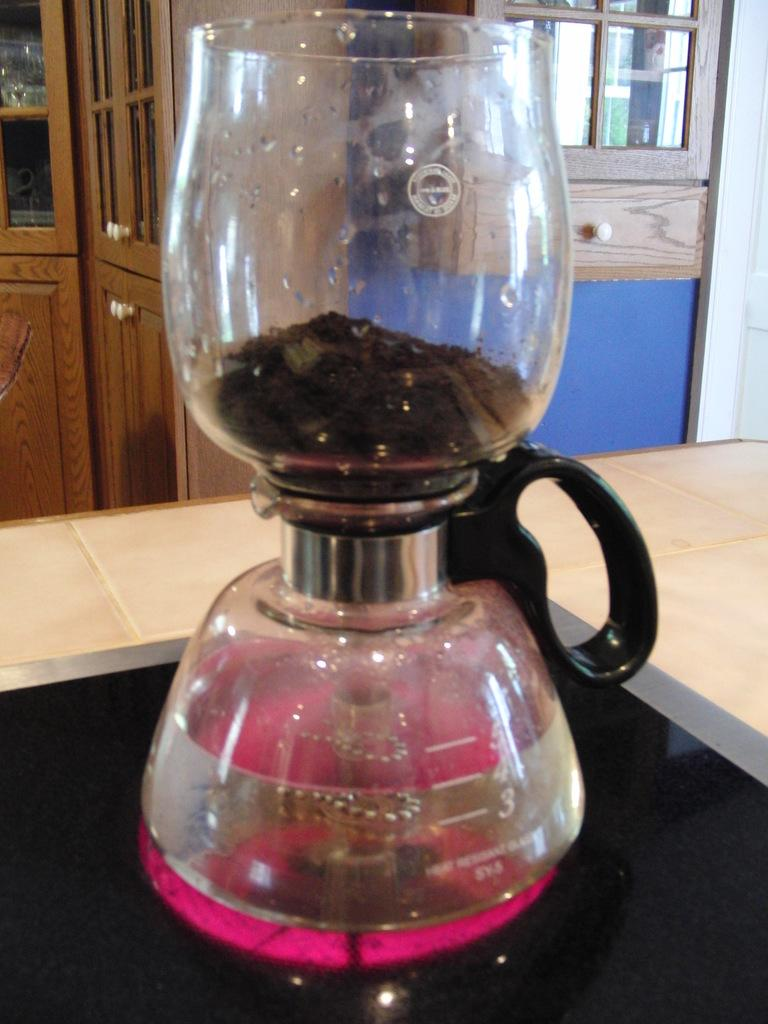<image>
Offer a succinct explanation of the picture presented. A coffee machine with the numbers 3-5 on the lower glass part. 